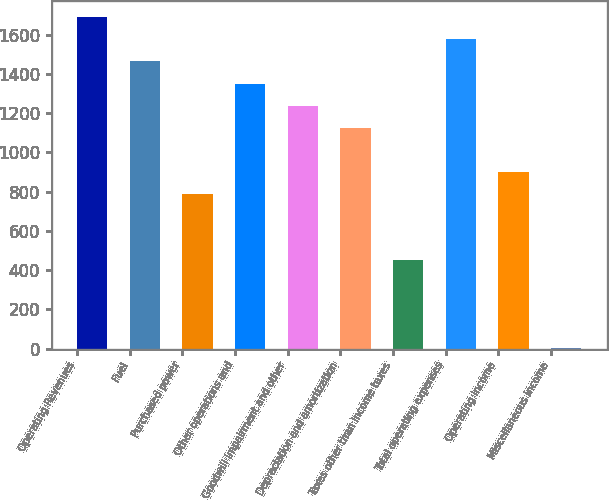<chart> <loc_0><loc_0><loc_500><loc_500><bar_chart><fcel>Operating Revenues<fcel>Fuel<fcel>Purchased power<fcel>Other operations and<fcel>Goodwill impairment and other<fcel>Depreciation and amortization<fcel>Taxes other than income taxes<fcel>Total operating expenses<fcel>Operating Income<fcel>Miscellaneous income<nl><fcel>1688.5<fcel>1463.5<fcel>788.5<fcel>1351<fcel>1238.5<fcel>1126<fcel>451<fcel>1576<fcel>901<fcel>1<nl></chart> 